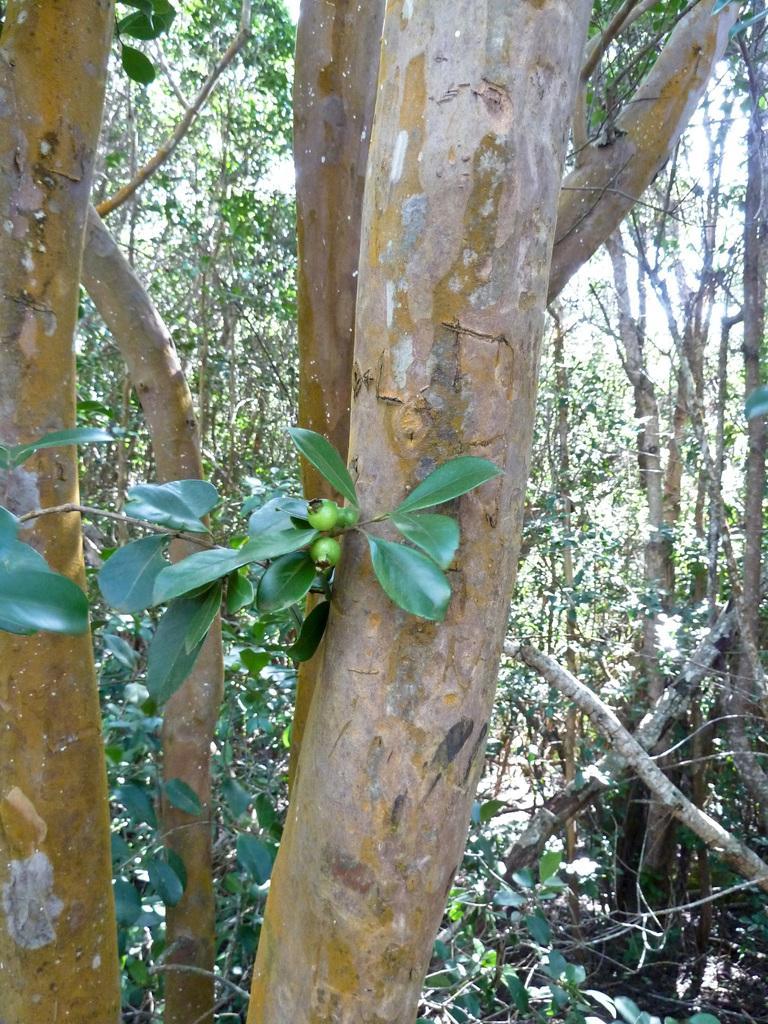Please provide a concise description of this image. In front of the picture, we see the stems of the trees and the fruits in green color. There are trees in the background. This picture might be clicked in the garden or in the forest. 